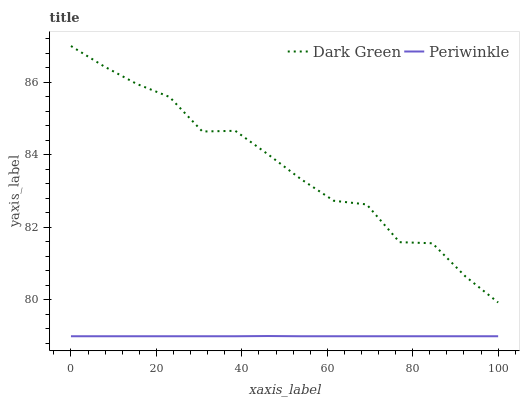Does Periwinkle have the minimum area under the curve?
Answer yes or no. Yes. Does Dark Green have the maximum area under the curve?
Answer yes or no. Yes. Does Dark Green have the minimum area under the curve?
Answer yes or no. No. Is Periwinkle the smoothest?
Answer yes or no. Yes. Is Dark Green the roughest?
Answer yes or no. Yes. Is Dark Green the smoothest?
Answer yes or no. No. Does Periwinkle have the lowest value?
Answer yes or no. Yes. Does Dark Green have the lowest value?
Answer yes or no. No. Does Dark Green have the highest value?
Answer yes or no. Yes. Is Periwinkle less than Dark Green?
Answer yes or no. Yes. Is Dark Green greater than Periwinkle?
Answer yes or no. Yes. Does Periwinkle intersect Dark Green?
Answer yes or no. No. 